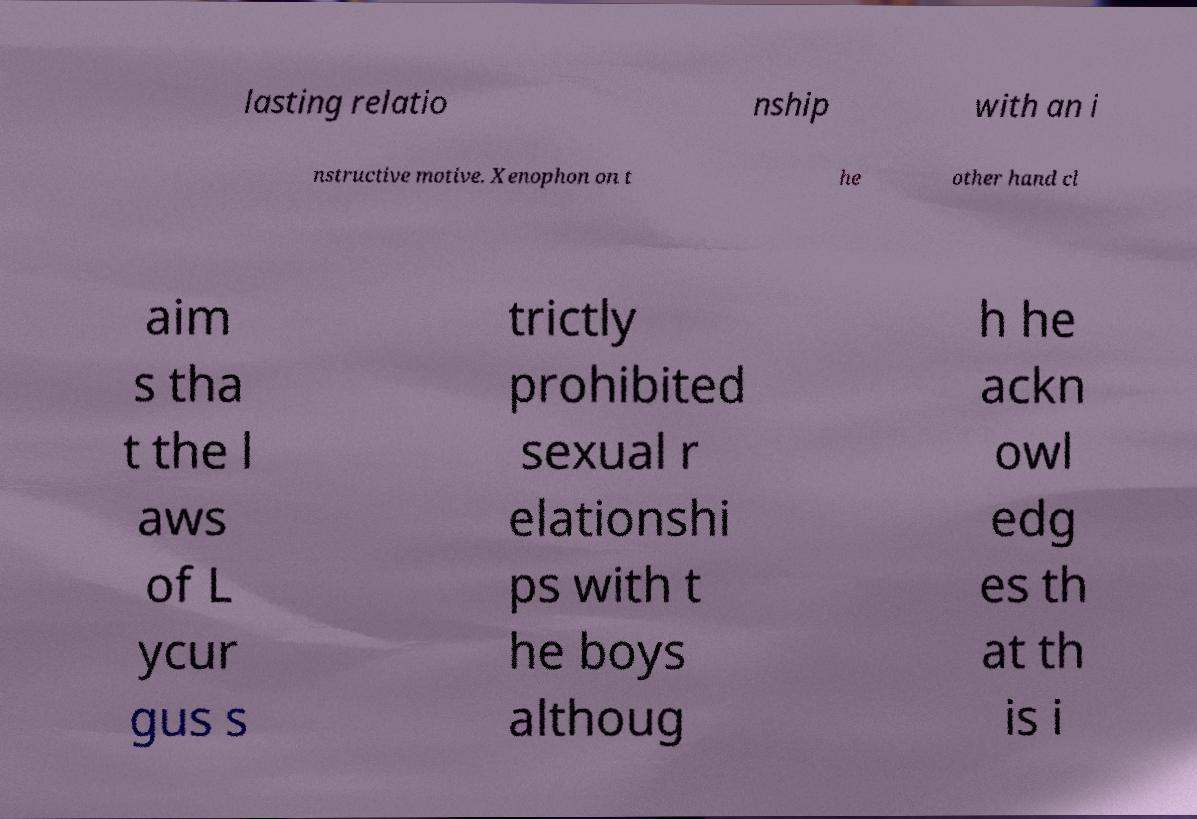Could you assist in decoding the text presented in this image and type it out clearly? lasting relatio nship with an i nstructive motive. Xenophon on t he other hand cl aim s tha t the l aws of L ycur gus s trictly prohibited sexual r elationshi ps with t he boys althoug h he ackn owl edg es th at th is i 